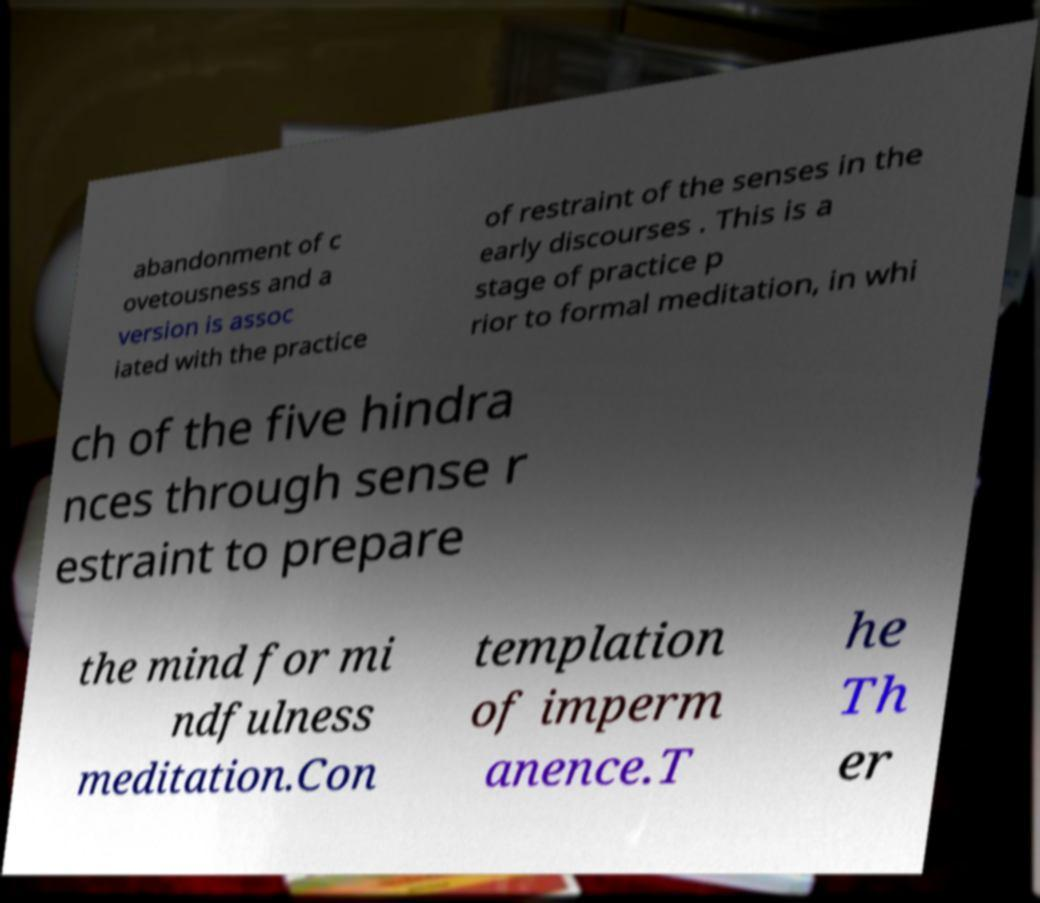Please identify and transcribe the text found in this image. abandonment of c ovetousness and a version is assoc iated with the practice of restraint of the senses in the early discourses . This is a stage of practice p rior to formal meditation, in whi ch of the five hindra nces through sense r estraint to prepare the mind for mi ndfulness meditation.Con templation of imperm anence.T he Th er 